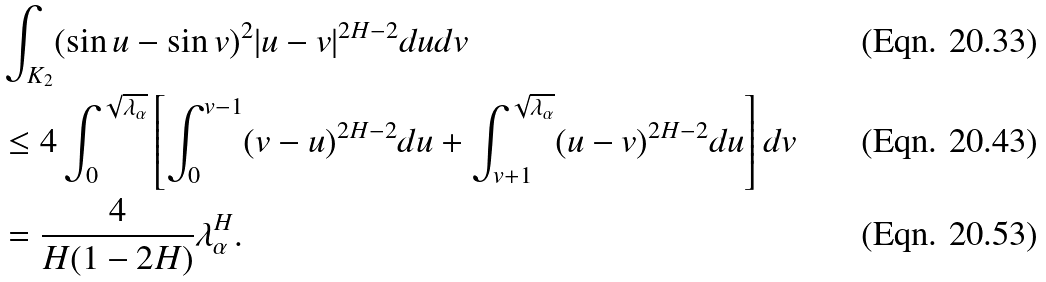<formula> <loc_0><loc_0><loc_500><loc_500>& \int _ { K _ { 2 } } ( \sin u - \sin v ) ^ { 2 } | u - v | ^ { 2 H - 2 } d u d v \\ & \leq 4 \int _ { 0 } ^ { \sqrt { \lambda _ { \alpha } } } \left [ \int _ { 0 } ^ { v - 1 } ( v - u ) ^ { 2 H - 2 } d u + \int _ { v + 1 } ^ { \sqrt { \lambda _ { \alpha } } } ( u - v ) ^ { 2 H - 2 } d u \right ] d v \\ & = \frac { 4 } { H ( 1 - 2 H ) } \lambda _ { \alpha } ^ { H } .</formula> 